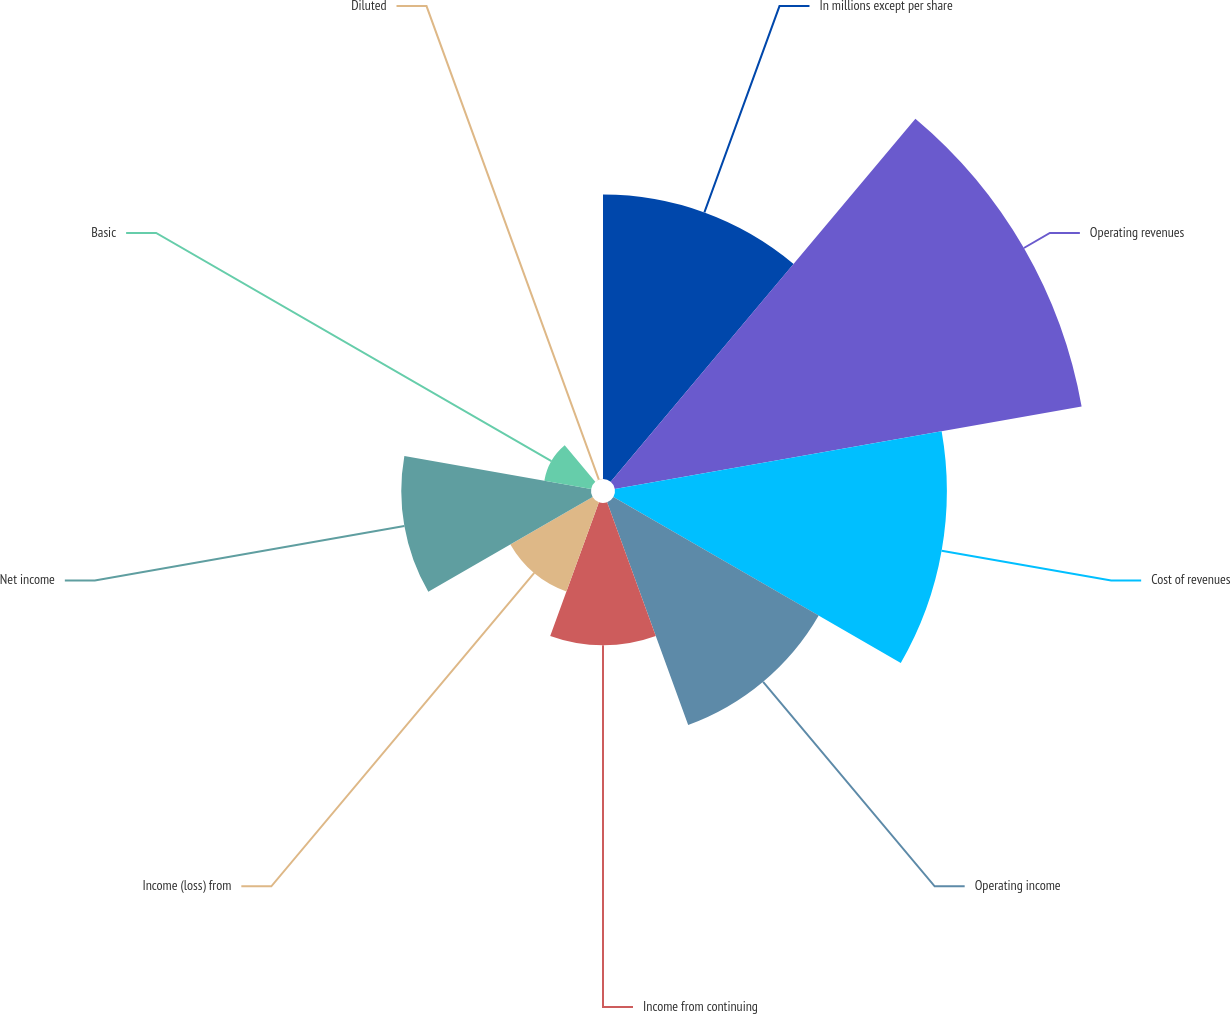<chart> <loc_0><loc_0><loc_500><loc_500><pie_chart><fcel>In millions except per share<fcel>Operating revenues<fcel>Cost of revenues<fcel>Operating income<fcel>Income from continuing<fcel>Income (loss) from<fcel>Net income<fcel>Basic<fcel>Diluted<nl><fcel>15.79%<fcel>26.31%<fcel>18.42%<fcel>13.16%<fcel>7.9%<fcel>5.27%<fcel>10.53%<fcel>2.64%<fcel>0.01%<nl></chart> 